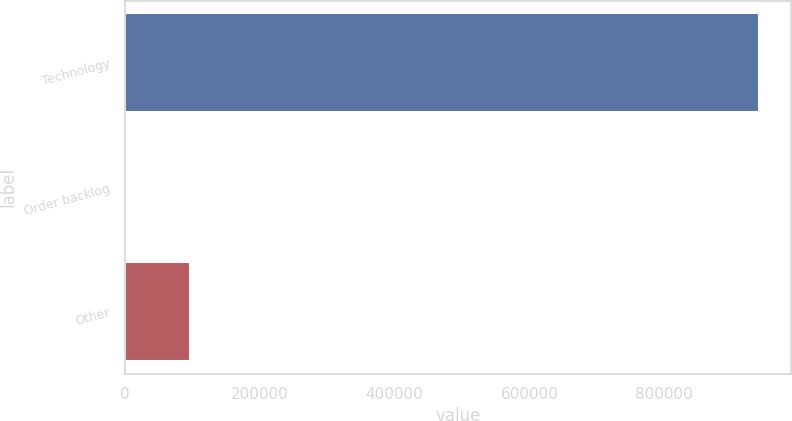<chart> <loc_0><loc_0><loc_500><loc_500><bar_chart><fcel>Technology<fcel>Order backlog<fcel>Other<nl><fcel>941081<fcel>2332<fcel>96206.9<nl></chart> 